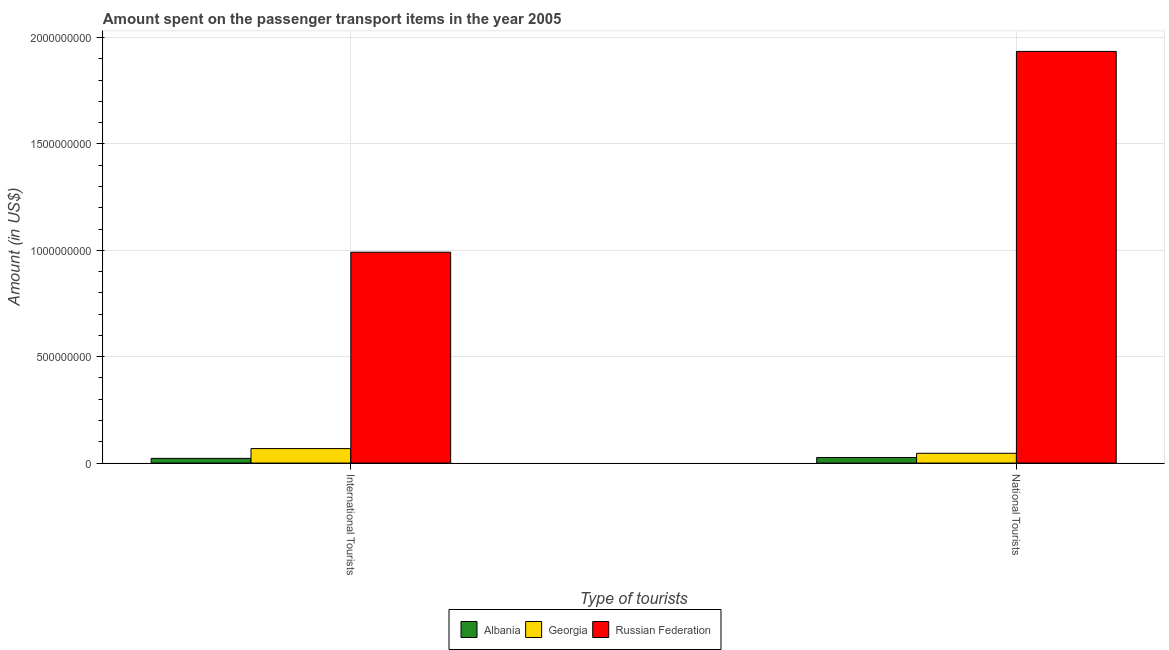How many groups of bars are there?
Your answer should be compact. 2. Are the number of bars per tick equal to the number of legend labels?
Your response must be concise. Yes. How many bars are there on the 1st tick from the left?
Make the answer very short. 3. What is the label of the 2nd group of bars from the left?
Offer a terse response. National Tourists. What is the amount spent on transport items of international tourists in Russian Federation?
Offer a terse response. 9.91e+08. Across all countries, what is the maximum amount spent on transport items of international tourists?
Your answer should be compact. 9.91e+08. Across all countries, what is the minimum amount spent on transport items of national tourists?
Your response must be concise. 2.60e+07. In which country was the amount spent on transport items of national tourists maximum?
Your answer should be very brief. Russian Federation. In which country was the amount spent on transport items of national tourists minimum?
Provide a short and direct response. Albania. What is the total amount spent on transport items of international tourists in the graph?
Your response must be concise. 1.08e+09. What is the difference between the amount spent on transport items of international tourists in Georgia and that in Albania?
Keep it short and to the point. 4.60e+07. What is the difference between the amount spent on transport items of international tourists in Russian Federation and the amount spent on transport items of national tourists in Albania?
Ensure brevity in your answer.  9.65e+08. What is the average amount spent on transport items of international tourists per country?
Ensure brevity in your answer.  3.60e+08. What is the difference between the amount spent on transport items of national tourists and amount spent on transport items of international tourists in Albania?
Provide a succinct answer. 4.00e+06. In how many countries, is the amount spent on transport items of international tourists greater than 300000000 US$?
Provide a short and direct response. 1. What is the ratio of the amount spent on transport items of international tourists in Russian Federation to that in Georgia?
Offer a very short reply. 14.57. What does the 3rd bar from the left in National Tourists represents?
Offer a terse response. Russian Federation. What does the 3rd bar from the right in National Tourists represents?
Offer a very short reply. Albania. How many bars are there?
Give a very brief answer. 6. Are all the bars in the graph horizontal?
Your answer should be compact. No. Does the graph contain grids?
Ensure brevity in your answer.  Yes. How are the legend labels stacked?
Offer a terse response. Horizontal. What is the title of the graph?
Offer a terse response. Amount spent on the passenger transport items in the year 2005. What is the label or title of the X-axis?
Offer a terse response. Type of tourists. What is the Amount (in US$) of Albania in International Tourists?
Make the answer very short. 2.20e+07. What is the Amount (in US$) of Georgia in International Tourists?
Your response must be concise. 6.80e+07. What is the Amount (in US$) of Russian Federation in International Tourists?
Offer a terse response. 9.91e+08. What is the Amount (in US$) in Albania in National Tourists?
Make the answer very short. 2.60e+07. What is the Amount (in US$) in Georgia in National Tourists?
Offer a very short reply. 4.60e+07. What is the Amount (in US$) of Russian Federation in National Tourists?
Keep it short and to the point. 1.94e+09. Across all Type of tourists, what is the maximum Amount (in US$) in Albania?
Offer a very short reply. 2.60e+07. Across all Type of tourists, what is the maximum Amount (in US$) in Georgia?
Provide a short and direct response. 6.80e+07. Across all Type of tourists, what is the maximum Amount (in US$) in Russian Federation?
Give a very brief answer. 1.94e+09. Across all Type of tourists, what is the minimum Amount (in US$) in Albania?
Make the answer very short. 2.20e+07. Across all Type of tourists, what is the minimum Amount (in US$) in Georgia?
Provide a short and direct response. 4.60e+07. Across all Type of tourists, what is the minimum Amount (in US$) of Russian Federation?
Keep it short and to the point. 9.91e+08. What is the total Amount (in US$) in Albania in the graph?
Offer a very short reply. 4.80e+07. What is the total Amount (in US$) in Georgia in the graph?
Provide a succinct answer. 1.14e+08. What is the total Amount (in US$) of Russian Federation in the graph?
Give a very brief answer. 2.93e+09. What is the difference between the Amount (in US$) of Albania in International Tourists and that in National Tourists?
Ensure brevity in your answer.  -4.00e+06. What is the difference between the Amount (in US$) of Georgia in International Tourists and that in National Tourists?
Your response must be concise. 2.20e+07. What is the difference between the Amount (in US$) in Russian Federation in International Tourists and that in National Tourists?
Offer a very short reply. -9.44e+08. What is the difference between the Amount (in US$) in Albania in International Tourists and the Amount (in US$) in Georgia in National Tourists?
Make the answer very short. -2.40e+07. What is the difference between the Amount (in US$) in Albania in International Tourists and the Amount (in US$) in Russian Federation in National Tourists?
Your answer should be very brief. -1.91e+09. What is the difference between the Amount (in US$) in Georgia in International Tourists and the Amount (in US$) in Russian Federation in National Tourists?
Offer a very short reply. -1.87e+09. What is the average Amount (in US$) in Albania per Type of tourists?
Your answer should be compact. 2.40e+07. What is the average Amount (in US$) of Georgia per Type of tourists?
Give a very brief answer. 5.70e+07. What is the average Amount (in US$) of Russian Federation per Type of tourists?
Make the answer very short. 1.46e+09. What is the difference between the Amount (in US$) of Albania and Amount (in US$) of Georgia in International Tourists?
Keep it short and to the point. -4.60e+07. What is the difference between the Amount (in US$) of Albania and Amount (in US$) of Russian Federation in International Tourists?
Your answer should be compact. -9.69e+08. What is the difference between the Amount (in US$) of Georgia and Amount (in US$) of Russian Federation in International Tourists?
Provide a short and direct response. -9.23e+08. What is the difference between the Amount (in US$) of Albania and Amount (in US$) of Georgia in National Tourists?
Make the answer very short. -2.00e+07. What is the difference between the Amount (in US$) of Albania and Amount (in US$) of Russian Federation in National Tourists?
Give a very brief answer. -1.91e+09. What is the difference between the Amount (in US$) in Georgia and Amount (in US$) in Russian Federation in National Tourists?
Provide a succinct answer. -1.89e+09. What is the ratio of the Amount (in US$) in Albania in International Tourists to that in National Tourists?
Offer a very short reply. 0.85. What is the ratio of the Amount (in US$) of Georgia in International Tourists to that in National Tourists?
Provide a short and direct response. 1.48. What is the ratio of the Amount (in US$) of Russian Federation in International Tourists to that in National Tourists?
Offer a very short reply. 0.51. What is the difference between the highest and the second highest Amount (in US$) in Albania?
Offer a terse response. 4.00e+06. What is the difference between the highest and the second highest Amount (in US$) in Georgia?
Your response must be concise. 2.20e+07. What is the difference between the highest and the second highest Amount (in US$) of Russian Federation?
Offer a very short reply. 9.44e+08. What is the difference between the highest and the lowest Amount (in US$) in Albania?
Make the answer very short. 4.00e+06. What is the difference between the highest and the lowest Amount (in US$) in Georgia?
Ensure brevity in your answer.  2.20e+07. What is the difference between the highest and the lowest Amount (in US$) of Russian Federation?
Provide a succinct answer. 9.44e+08. 